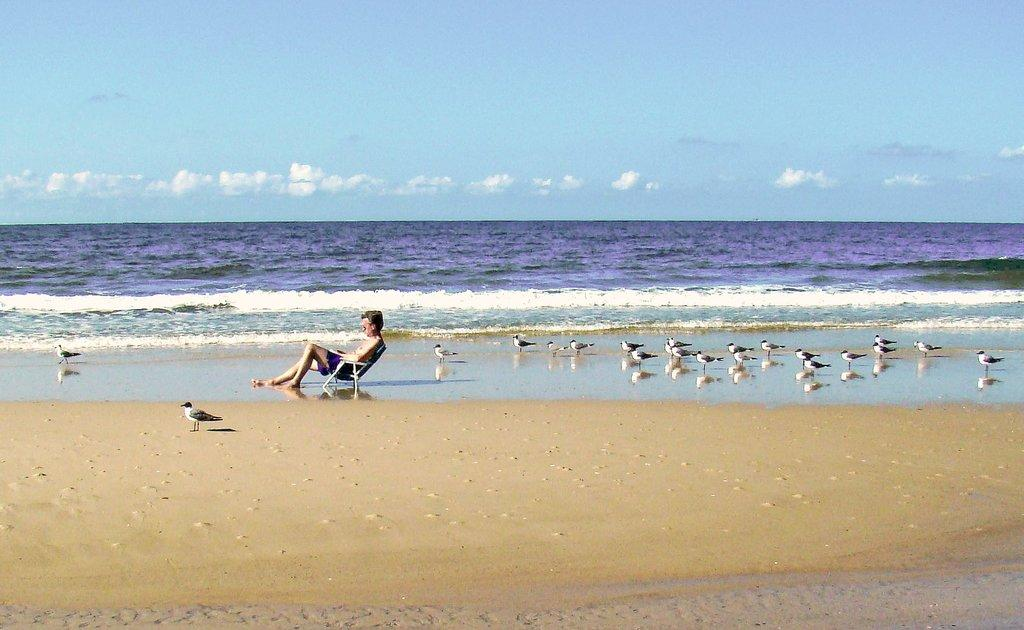Where is the image taken? The image is taken at a sea beach. What can be seen on the beach in the image? There is a person sitting on a chair and birds on the beach. What is visible in the background of the image? The background of the image includes the sea. How would you describe the sky in the image? The sky is cloudy in the image. What verse is the person reciting on the beach in the image? There is no indication in the image that the person is reciting a verse. What is the name of the bird that can be seen flying in the image? There are no birds flying in the image; they are on the beach. Additionally, the bird species is not mentioned in the provided facts. 